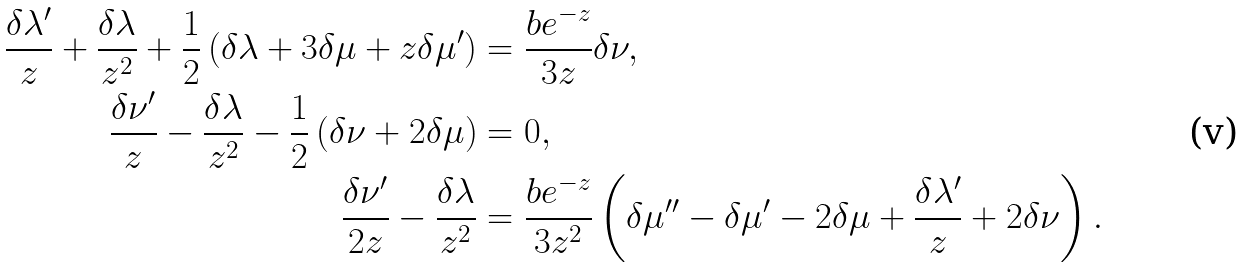<formula> <loc_0><loc_0><loc_500><loc_500>\frac { \delta \lambda ^ { \prime } } { z } + \frac { \delta \lambda } { z ^ { 2 } } + \frac { 1 } { 2 } \left ( \delta \lambda + 3 \delta \mu + z \delta \mu ^ { \prime } \right ) & = \frac { b e ^ { - z } } { 3 z } \delta \nu , \\ \frac { \delta \nu ^ { \prime } } { z } - \frac { \delta \lambda } { z ^ { 2 } } - \frac { 1 } { 2 } \left ( \delta \nu + 2 \delta \mu \right ) & = 0 , \\ \frac { \delta \nu ^ { \prime } } { 2 z } - \frac { \delta \lambda } { z ^ { 2 } } & = \frac { b e ^ { - z } } { 3 z ^ { 2 } } \left ( \delta \mu ^ { \prime \prime } - \delta \mu ^ { \prime } - 2 \delta \mu + \frac { \delta \lambda ^ { \prime } } { z } + 2 \delta \nu \right ) .</formula> 